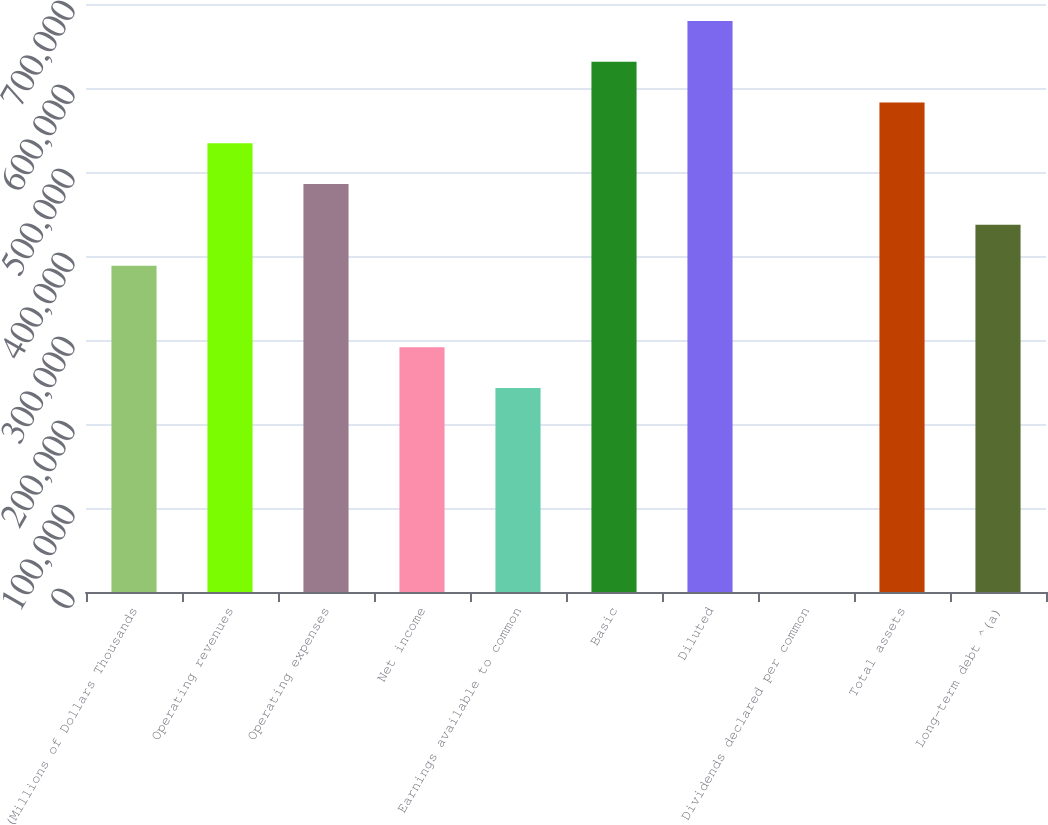<chart> <loc_0><loc_0><loc_500><loc_500><bar_chart><fcel>(Millions of Dollars Thousands<fcel>Operating revenues<fcel>Operating expenses<fcel>Net income<fcel>Earnings available to common<fcel>Basic<fcel>Diluted<fcel>Dividends declared per common<fcel>Total assets<fcel>Long-term debt ^(a)<nl><fcel>388492<fcel>534176<fcel>485615<fcel>291369<fcel>242808<fcel>631299<fcel>679861<fcel>1.03<fcel>582738<fcel>437054<nl></chart> 